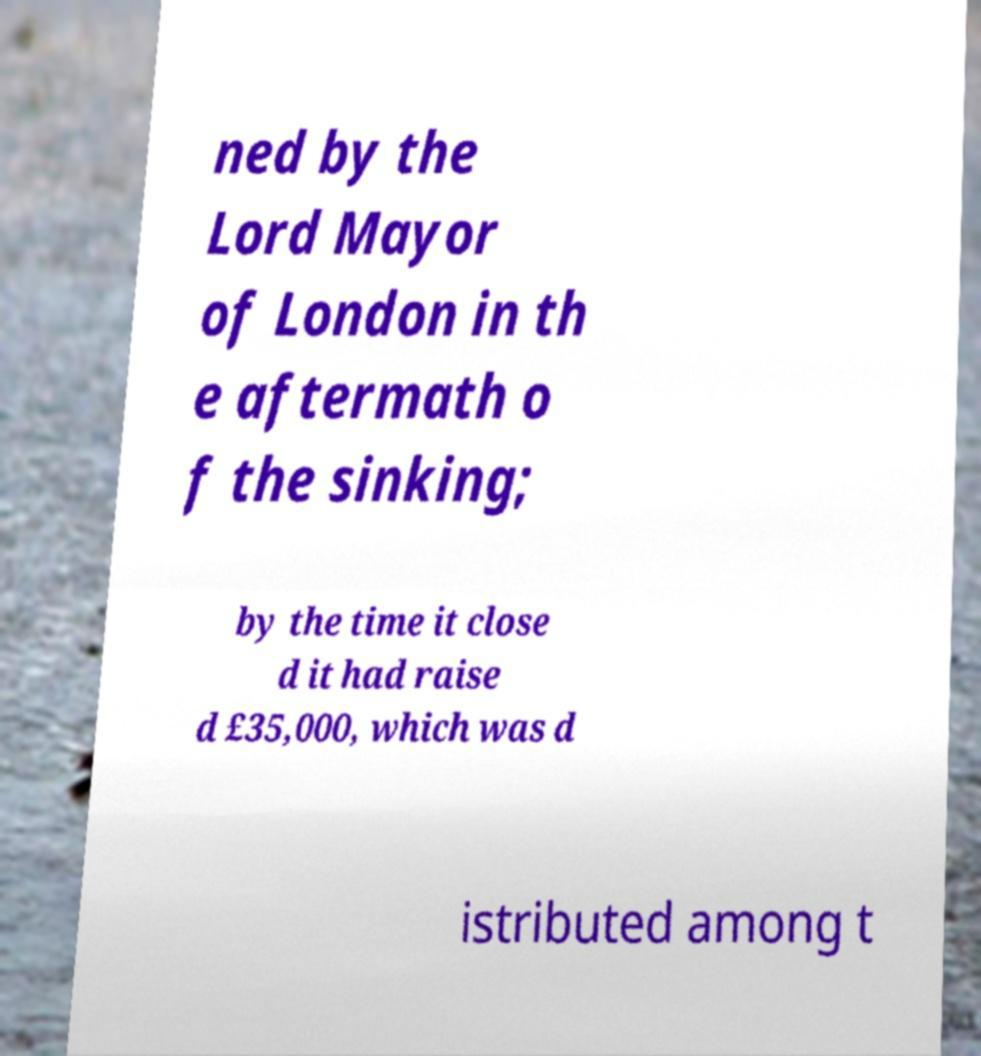Could you extract and type out the text from this image? ned by the Lord Mayor of London in th e aftermath o f the sinking; by the time it close d it had raise d £35,000, which was d istributed among t 